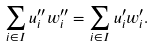Convert formula to latex. <formula><loc_0><loc_0><loc_500><loc_500>\sum _ { i \in I } u ^ { \prime \prime } _ { i } w ^ { \prime \prime } _ { i } = \sum _ { i \in I } u ^ { \prime } _ { i } w ^ { \prime } _ { i } .</formula> 